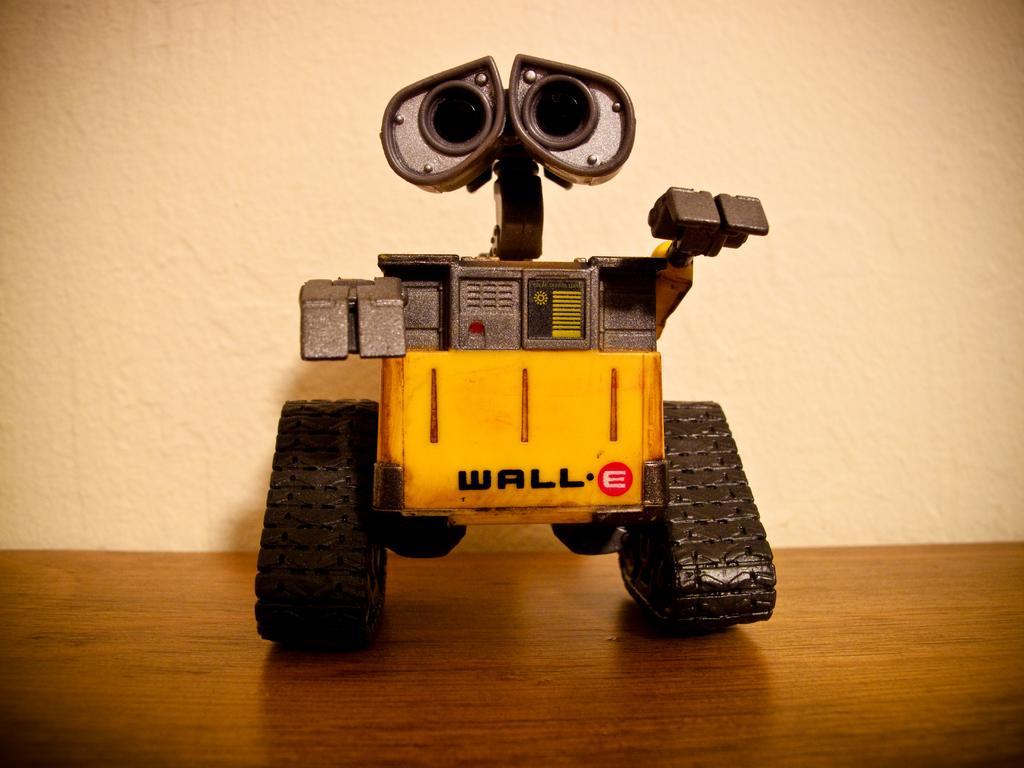In one or two sentences, can you explain what this image depicts? In this picture we can see a toy vehicle on a table and in the background we can see wall. 